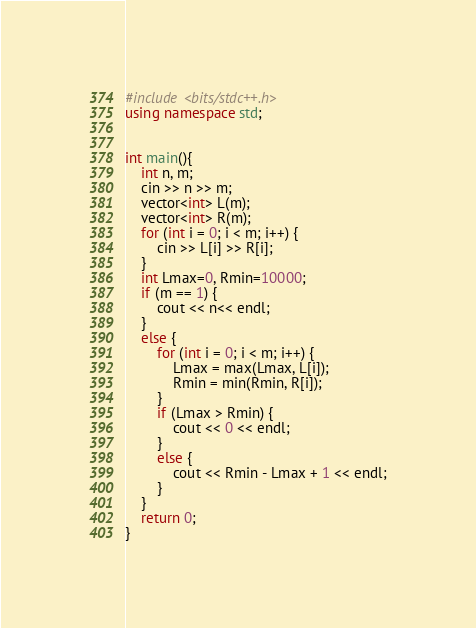Convert code to text. <code><loc_0><loc_0><loc_500><loc_500><_C++_>#include <bits/stdc++.h>
using namespace std;


int main(){
	int n, m;
	cin >> n >> m;
	vector<int> L(m);
	vector<int> R(m);
	for (int i = 0; i < m; i++) {
		cin >> L[i] >> R[i];
	}
	int Lmax=0, Rmin=10000;
	if (m == 1) {
		cout << n<< endl;
	}
	else {
		for (int i = 0; i < m; i++) {
			Lmax = max(Lmax, L[i]);
			Rmin = min(Rmin, R[i]);
		}
		if (Lmax > Rmin) {
			cout << 0 << endl;
		}
		else {
			cout << Rmin - Lmax + 1 << endl;
		}
	}
	return 0;
}</code> 